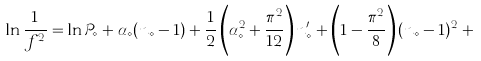<formula> <loc_0><loc_0><loc_500><loc_500>\ln \frac { 1 } { f ^ { 2 } } = \ln \mathcal { P } _ { \diamond } + \alpha _ { \diamond } ( n _ { \diamond } - 1 ) + \frac { 1 } { 2 } \left ( \alpha _ { \diamond } ^ { 2 } + \frac { \pi ^ { 2 } } { 1 2 } \right ) n ^ { \prime } _ { \diamond } + \left ( 1 - \frac { \pi ^ { 2 } } { 8 } \right ) ( n _ { \diamond } - 1 ) ^ { 2 } + \cdots</formula> 